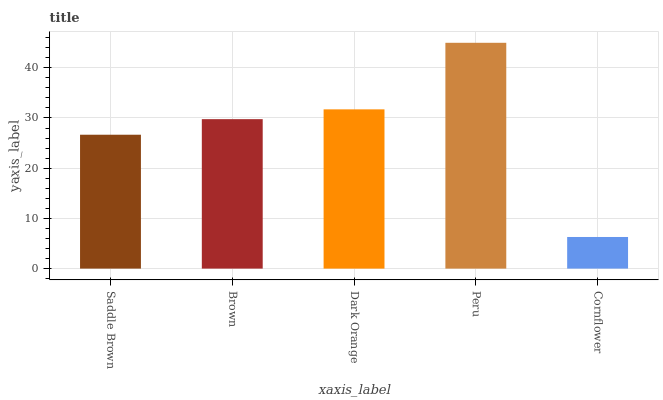Is Cornflower the minimum?
Answer yes or no. Yes. Is Peru the maximum?
Answer yes or no. Yes. Is Brown the minimum?
Answer yes or no. No. Is Brown the maximum?
Answer yes or no. No. Is Brown greater than Saddle Brown?
Answer yes or no. Yes. Is Saddle Brown less than Brown?
Answer yes or no. Yes. Is Saddle Brown greater than Brown?
Answer yes or no. No. Is Brown less than Saddle Brown?
Answer yes or no. No. Is Brown the high median?
Answer yes or no. Yes. Is Brown the low median?
Answer yes or no. Yes. Is Cornflower the high median?
Answer yes or no. No. Is Cornflower the low median?
Answer yes or no. No. 